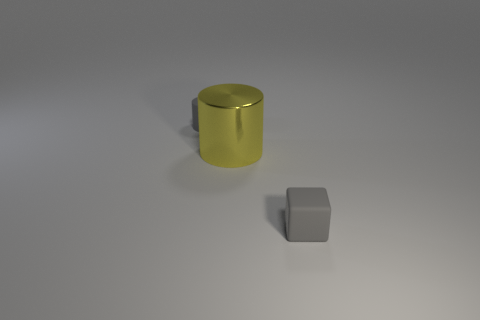Is there any other thing that is the same size as the yellow cylinder?
Offer a very short reply. No. How many other objects are the same shape as the big metallic thing?
Your response must be concise. 1. Do the yellow cylinder and the gray matte block have the same size?
Your answer should be compact. No. Is there a big gray block?
Give a very brief answer. No. Is there anything else that is the same material as the large cylinder?
Offer a terse response. No. Is there a small cylinder made of the same material as the gray cube?
Your response must be concise. Yes. There is a cube that is the same size as the matte cylinder; what is its material?
Your answer should be compact. Rubber. What number of tiny matte things have the same shape as the big yellow thing?
Offer a very short reply. 1. How many gray cylinders are the same size as the gray matte block?
Ensure brevity in your answer.  1. There is a small gray thing that is the same shape as the large shiny object; what is it made of?
Give a very brief answer. Rubber. 